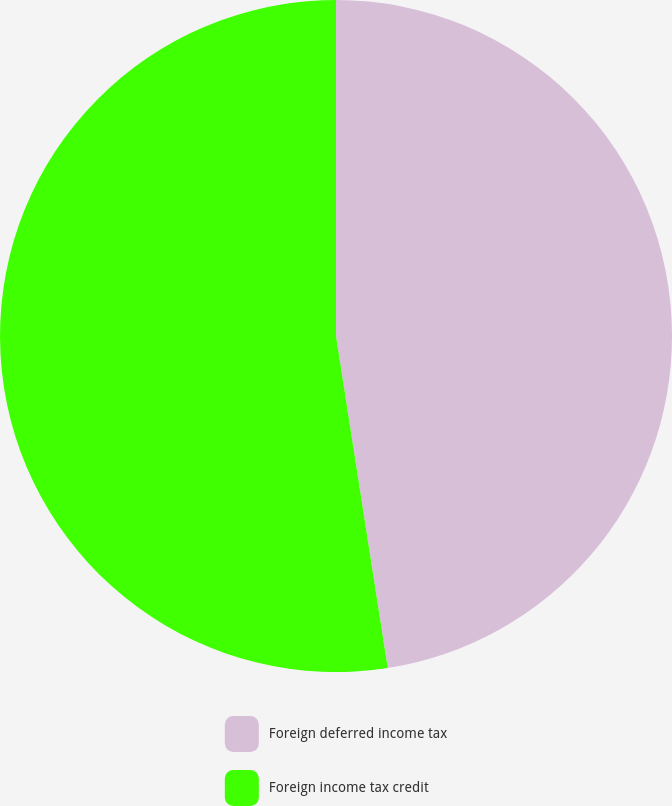Convert chart to OTSL. <chart><loc_0><loc_0><loc_500><loc_500><pie_chart><fcel>Foreign deferred income tax<fcel>Foreign income tax credit<nl><fcel>47.54%<fcel>52.46%<nl></chart> 